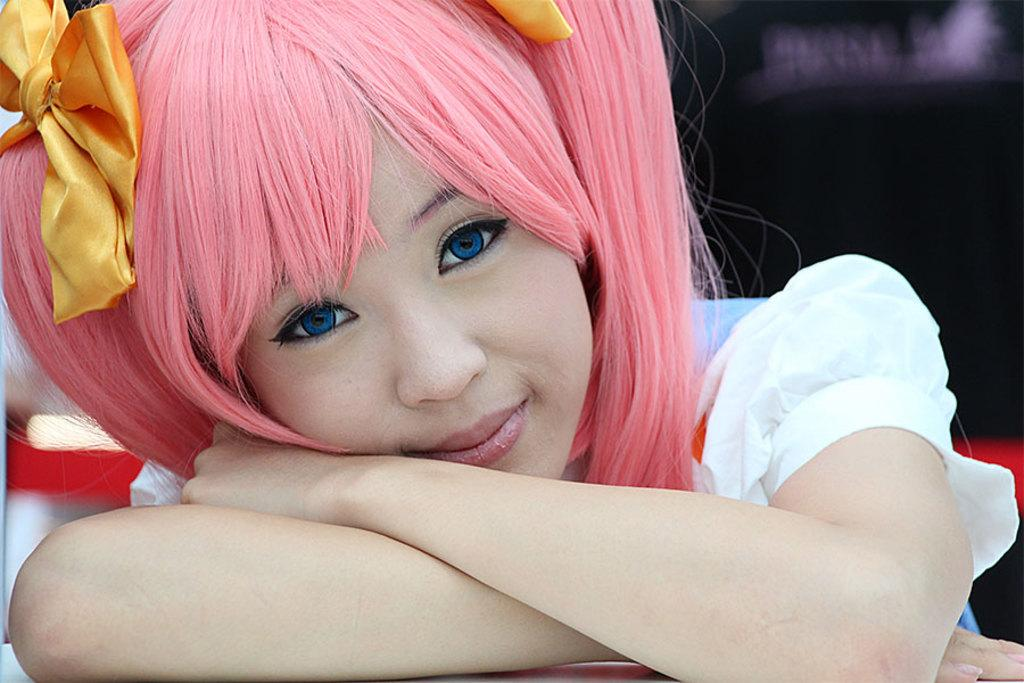Who is the main subject in the image? There is a girl in the image. What is the girl wearing? The girl is wearing a white dress. What color are the girl's eyes? The girl has blue eyes. What expression does the girl have? The girl is smiling. What is unique about the girl's hair color? The girl has pink hair. How would you describe the background of the image? The background of the image is blurry. What type of fact can be found in the image? There are no facts present in the image; it is a photograph of a girl. What kind of quartz can be seen in the girl's hair? There is no quartz present in the image; the girl's hair is pink. 